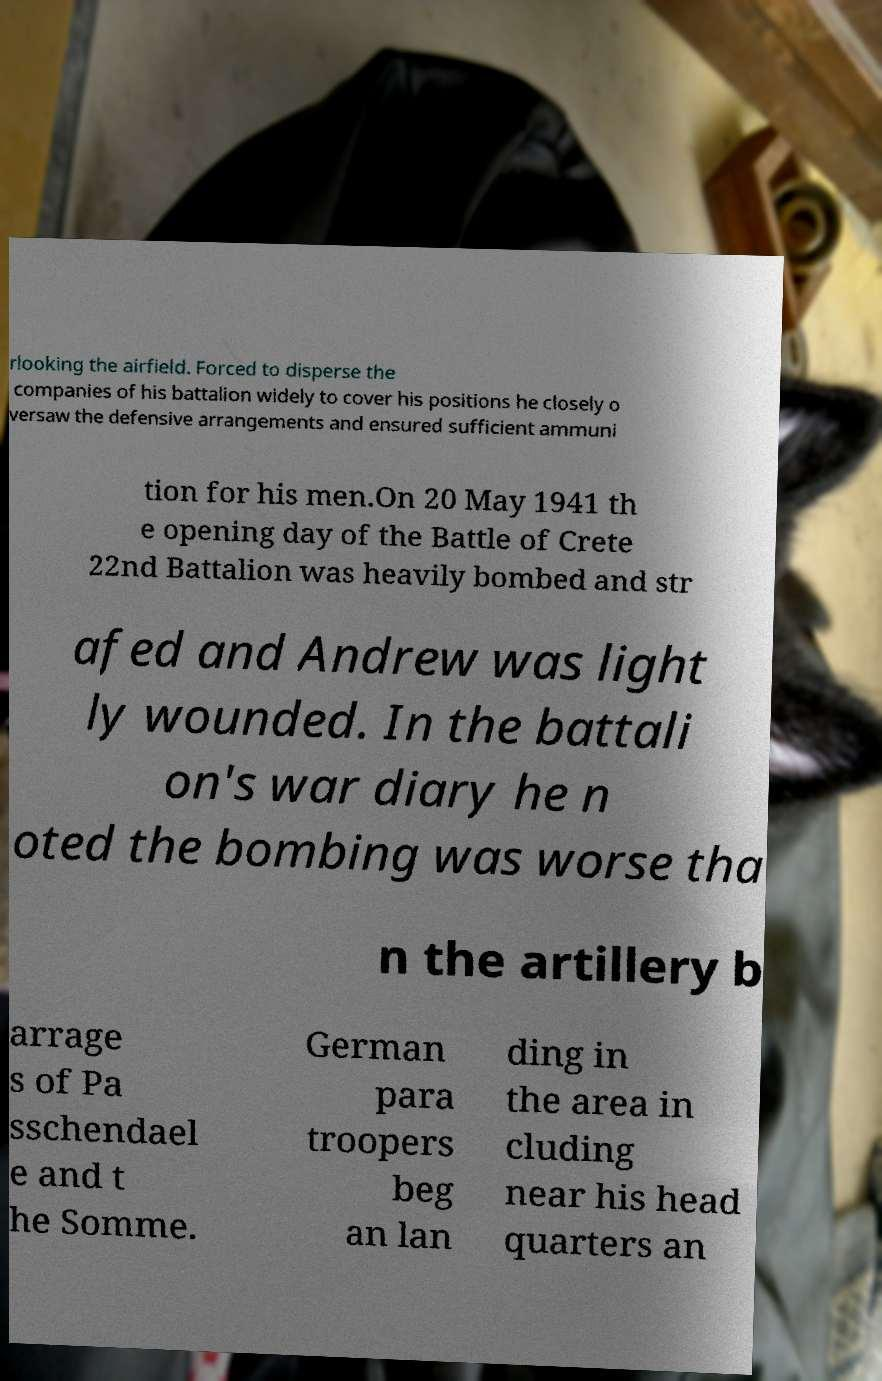Please read and relay the text visible in this image. What does it say? rlooking the airfield. Forced to disperse the companies of his battalion widely to cover his positions he closely o versaw the defensive arrangements and ensured sufficient ammuni tion for his men.On 20 May 1941 th e opening day of the Battle of Crete 22nd Battalion was heavily bombed and str afed and Andrew was light ly wounded. In the battali on's war diary he n oted the bombing was worse tha n the artillery b arrage s of Pa sschendael e and t he Somme. German para troopers beg an lan ding in the area in cluding near his head quarters an 